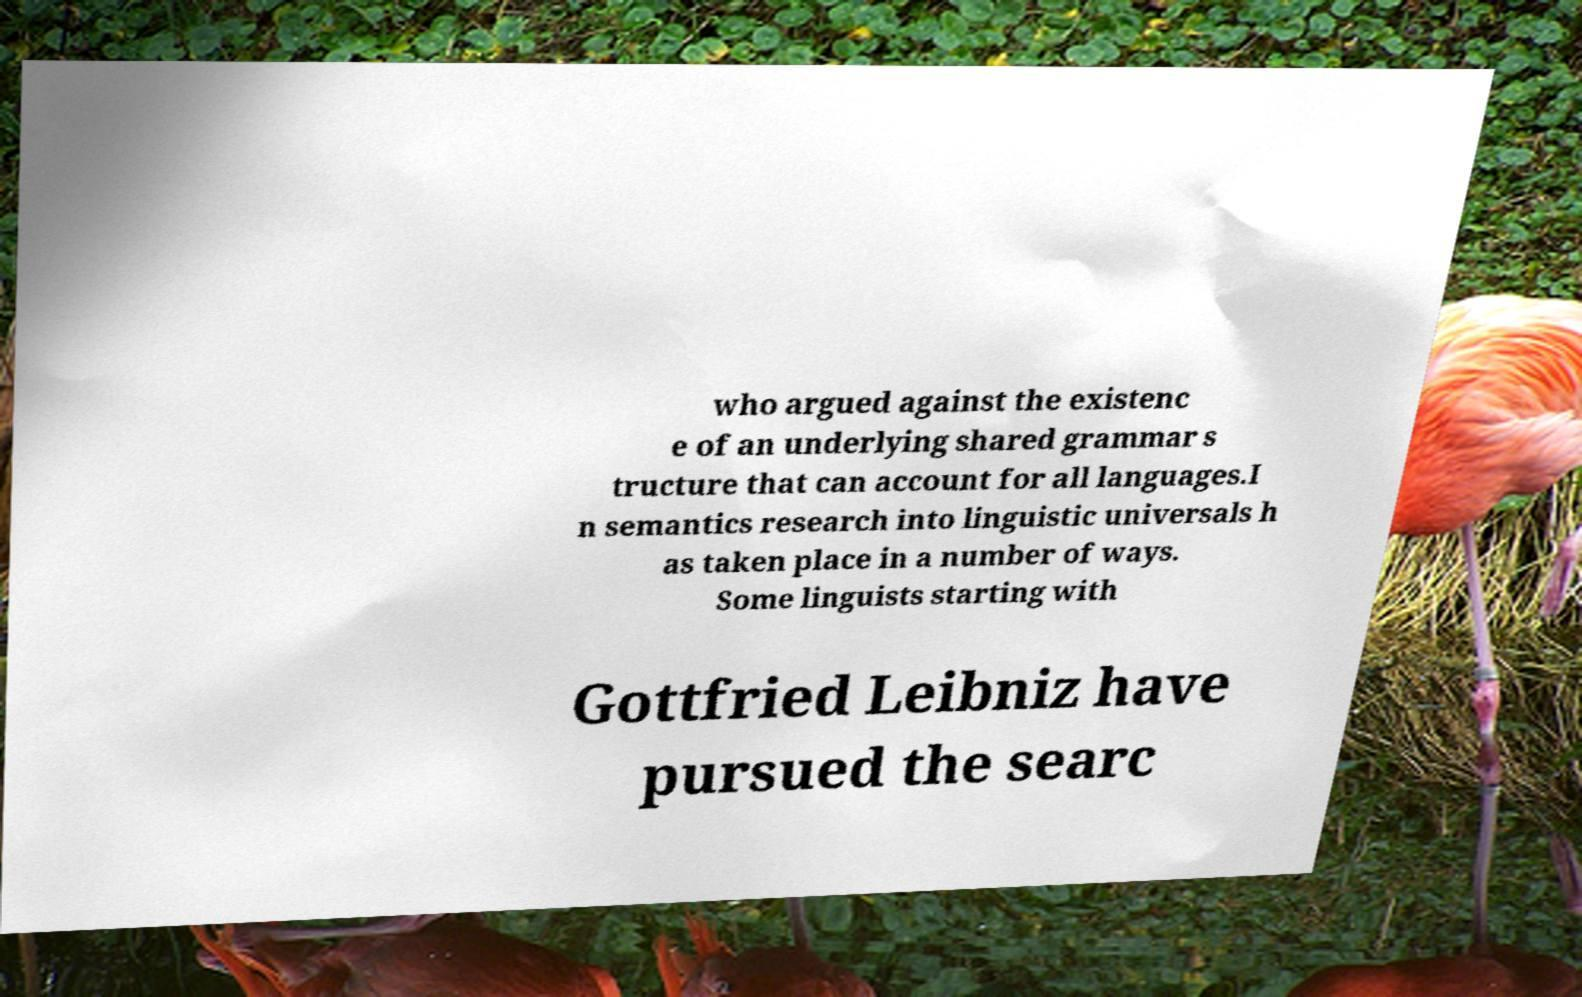Can you accurately transcribe the text from the provided image for me? who argued against the existenc e of an underlying shared grammar s tructure that can account for all languages.I n semantics research into linguistic universals h as taken place in a number of ways. Some linguists starting with Gottfried Leibniz have pursued the searc 